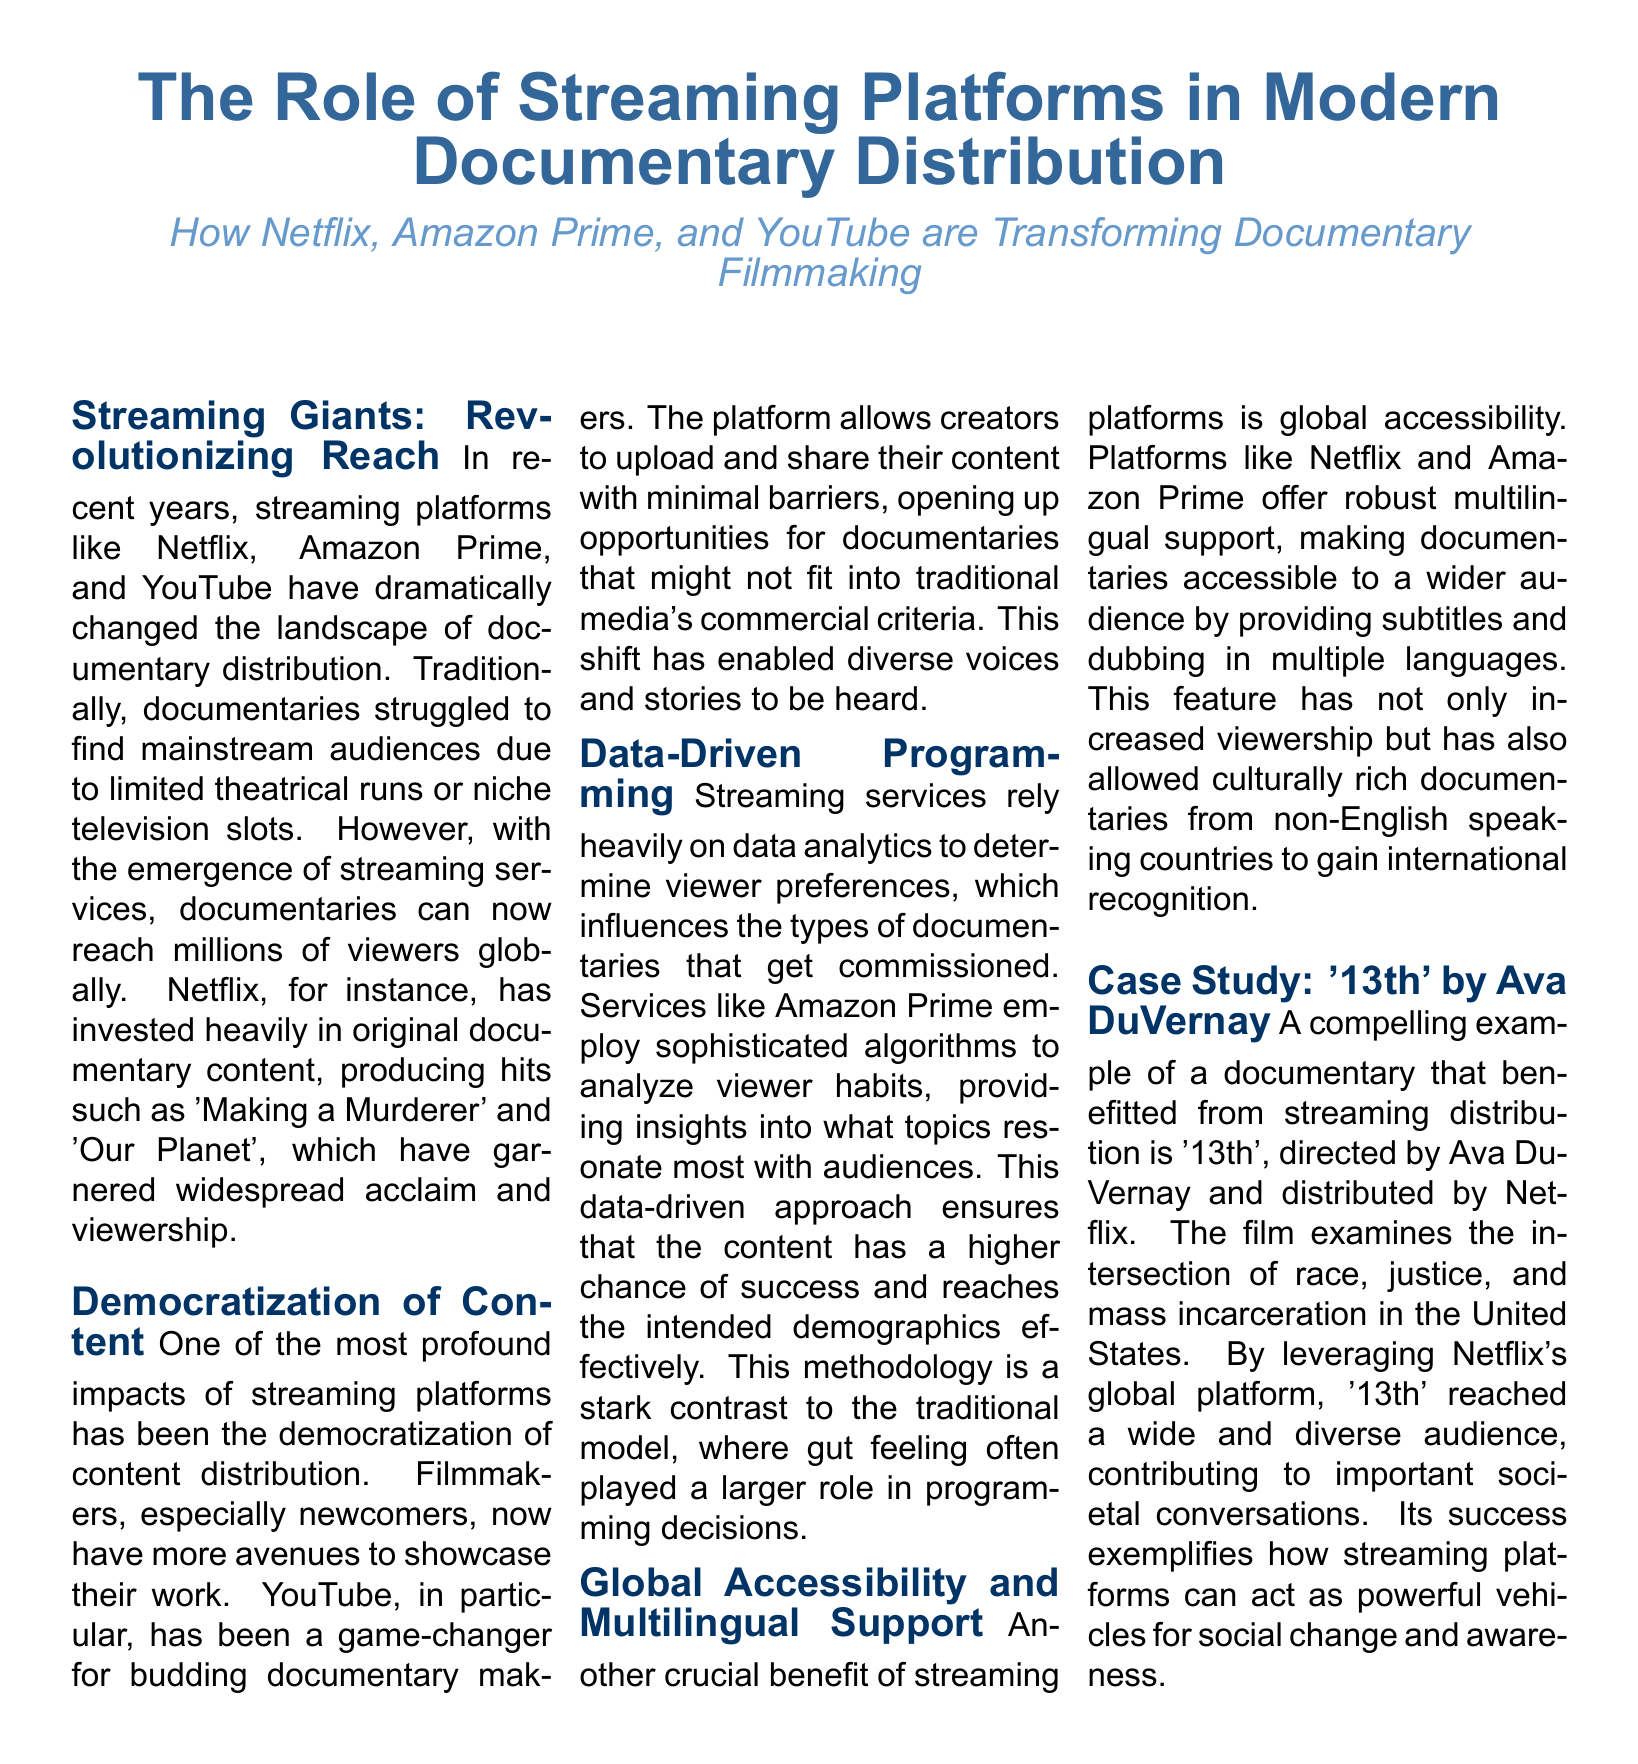what are three major streaming platforms mentioned? The document lists Netflix, Amazon Prime, and YouTube as the major platforms that have changed documentary distribution.
Answer: Netflix, Amazon Prime, YouTube what documentary was directed by Ava DuVernay? The document states that '13th' was directed by Ava DuVernay and discusses its distribution on Netflix.
Answer: '13th' how does streaming democratize content? According to the document, streaming platforms allow filmmakers, especially newcomers, to showcase their work without traditional media's commercial criteria.
Answer: By reducing barriers what type of programming approach do streaming services use? The document notes that streaming services use data-driven programming influenced by viewer preferences rather than gut feelings.
Answer: Data-driven programming what genre has seen an increase in reach due to streaming? The document focuses on the documentary genre, highlighting that it has reached millions of viewers globally due to streaming platforms.
Answer: Documentaries how has Netflix contributed to documentary visibility? The document emphasizes that Netflix has invested heavily in original documentary content, producing widely acclaimed titles that increased visibility.
Answer: By investing heavily what is a notable documentary produced by Netflix? The document mentions 'Making a Murderer' as a notable documentary produced by Netflix that has garnered acclaim.
Answer: 'Making a Murderer' what aspect of distribution does the case study focus on? The case study section focuses on the impact of streaming distribution on the documentary '13th' and its ability to reach diverse audiences.
Answer: Impact of streaming distribution how do streaming platforms enhance global accessibility? The document explains that streaming platforms provide multilingual support, which increases accessibility to documentaries worldwide.
Answer: Multilingual support 